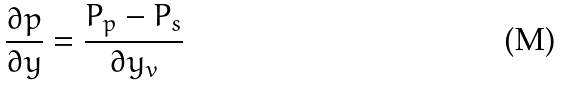Convert formula to latex. <formula><loc_0><loc_0><loc_500><loc_500>\frac { \partial p } { \partial y } = \frac { P _ { p } - P _ { s } } { \partial y _ { v } }</formula> 